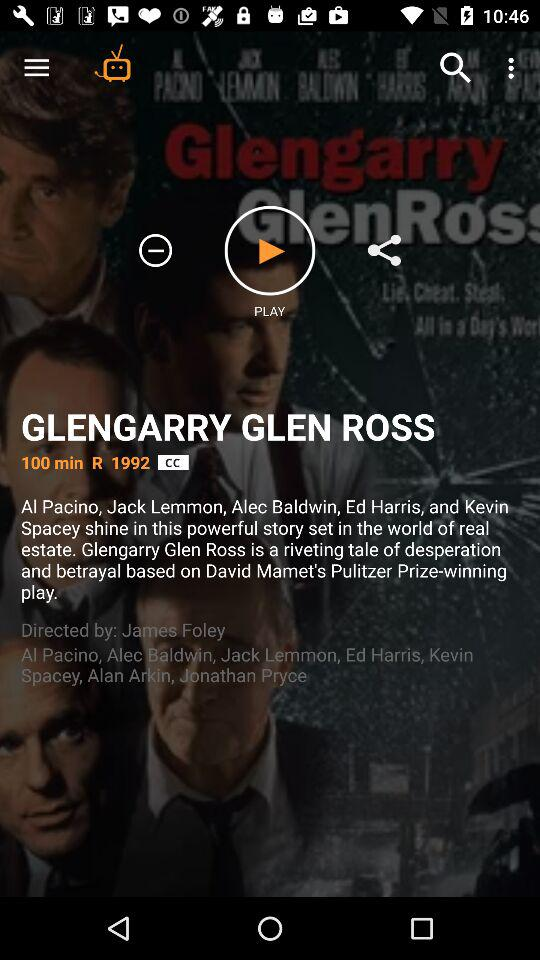What is the duration of the show? The duration of the show is 100 minutes. 